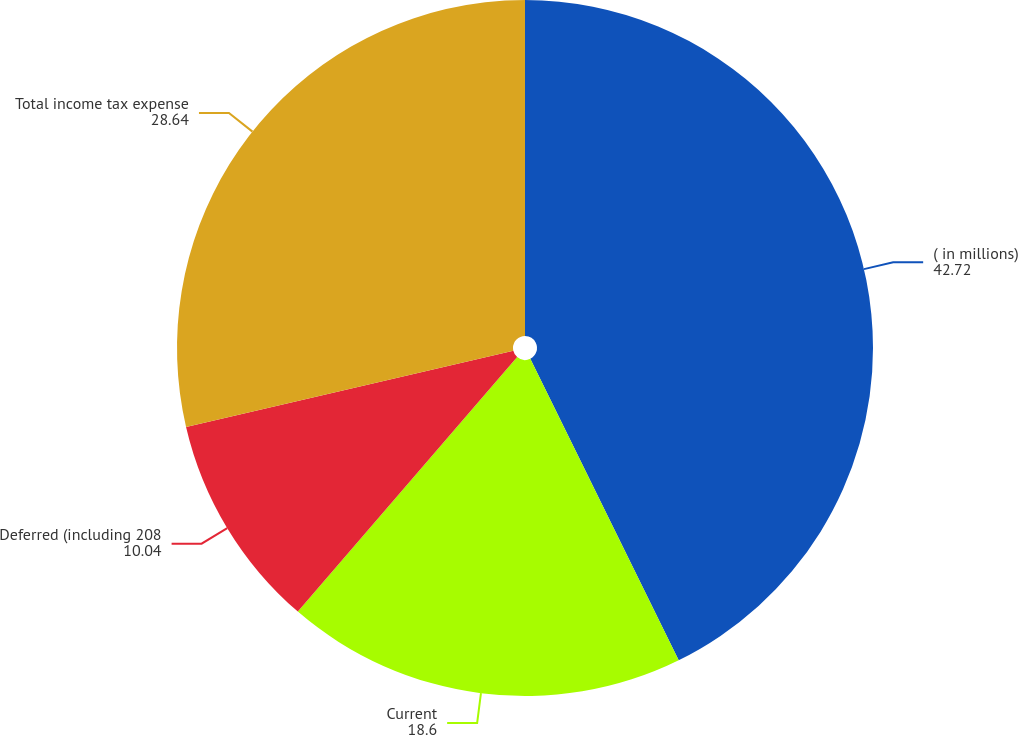<chart> <loc_0><loc_0><loc_500><loc_500><pie_chart><fcel>( in millions)<fcel>Current<fcel>Deferred (including 208<fcel>Total income tax expense<nl><fcel>42.72%<fcel>18.6%<fcel>10.04%<fcel>28.64%<nl></chart> 